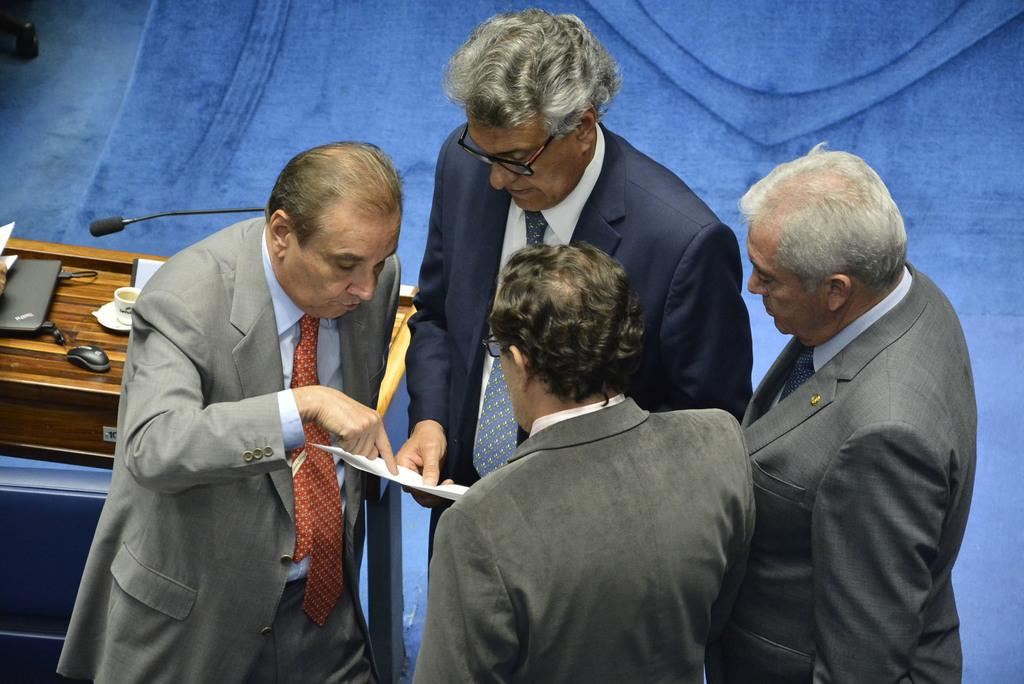How many people are in the image? There are four persons in the image. What are the people wearing? All four persons are wearing blazers. What can be seen on the left side of the image? There is a podium on the left side of the image. What items are on the podium? A laptop, a mouse, a microphone, and a cup are on the podium. What type of shoe can be seen on the podium? There is no shoe present on the podium in the image. 